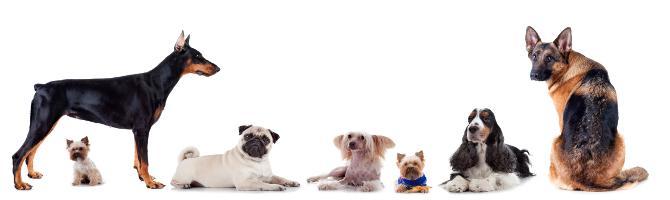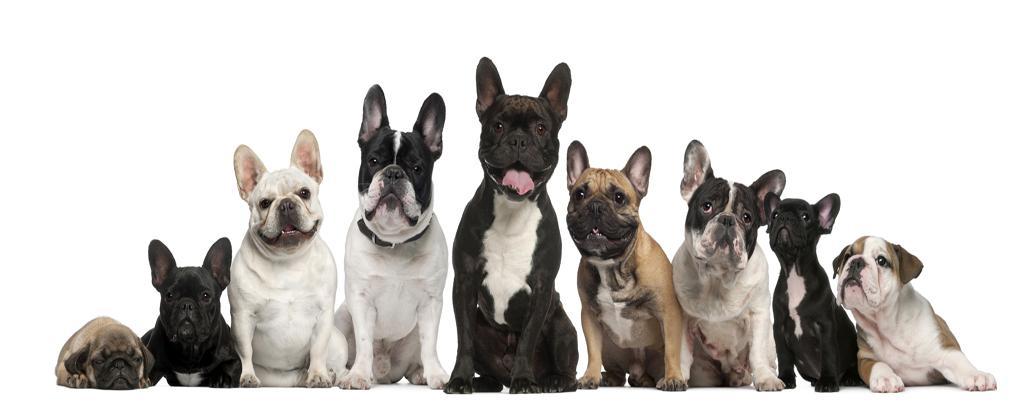The first image is the image on the left, the second image is the image on the right. Evaluate the accuracy of this statement regarding the images: "In the left image, a french bull dog puppy is standing and facing toward the right". Is it true? Answer yes or no. No. The first image is the image on the left, the second image is the image on the right. Examine the images to the left and right. Is the description "there are 4 togs in total" accurate? Answer yes or no. No. 